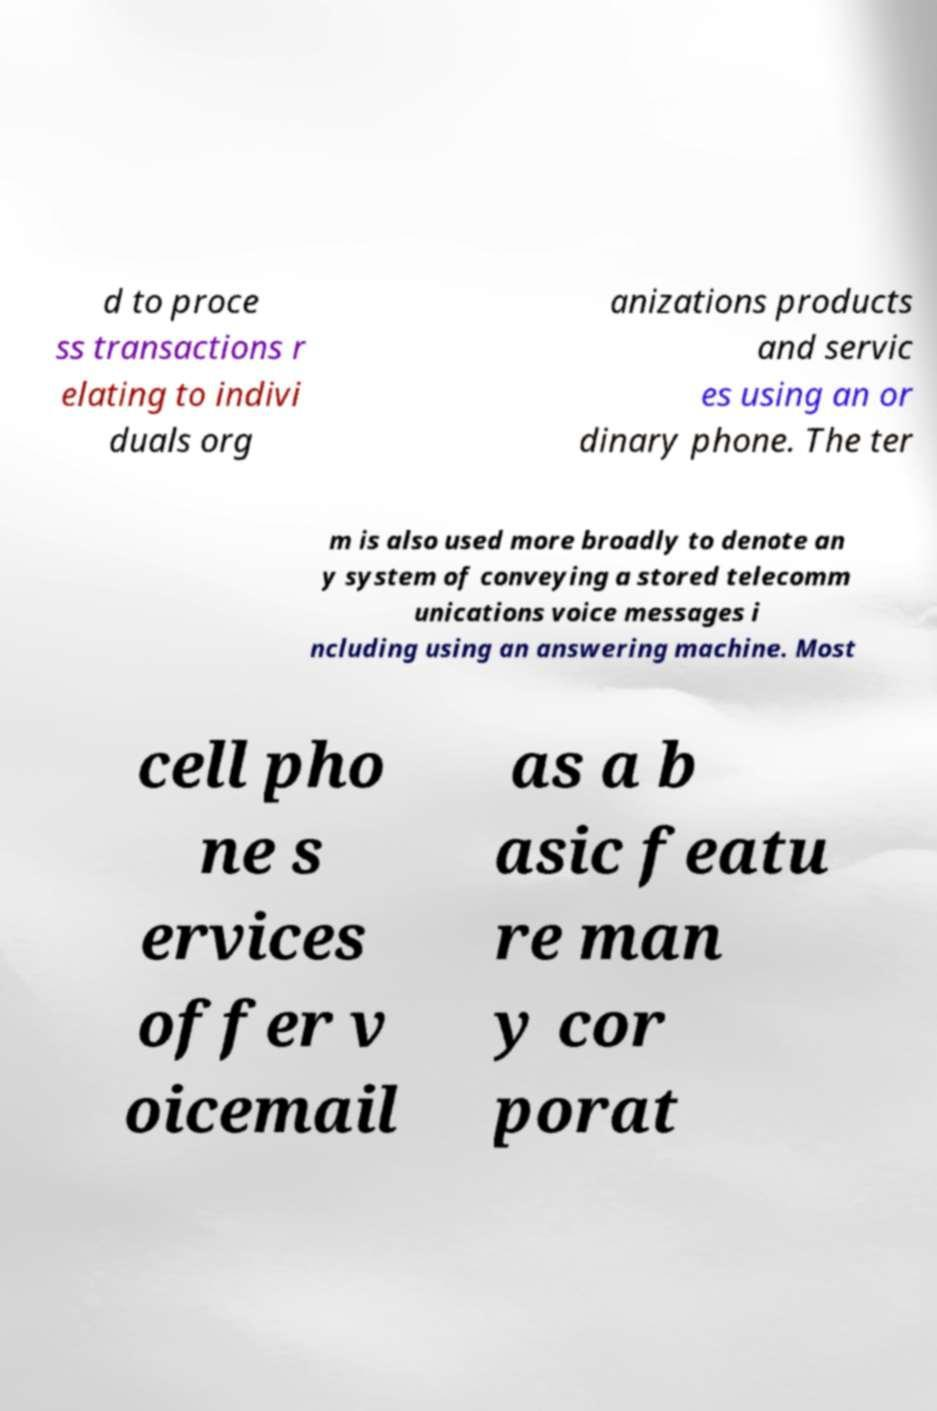Please read and relay the text visible in this image. What does it say? d to proce ss transactions r elating to indivi duals org anizations products and servic es using an or dinary phone. The ter m is also used more broadly to denote an y system of conveying a stored telecomm unications voice messages i ncluding using an answering machine. Most cell pho ne s ervices offer v oicemail as a b asic featu re man y cor porat 